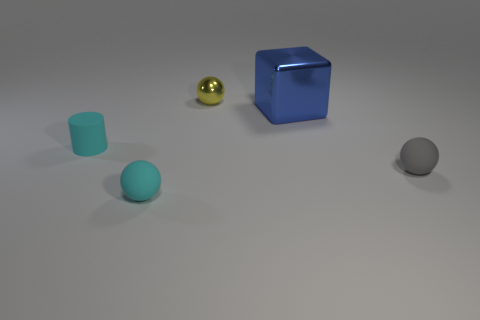Subtract 1 spheres. How many spheres are left? 2 Add 4 tiny red shiny blocks. How many objects exist? 9 Subtract all cylinders. How many objects are left? 4 Subtract 0 purple cylinders. How many objects are left? 5 Subtract all yellow things. Subtract all blue metal things. How many objects are left? 3 Add 3 blue cubes. How many blue cubes are left? 4 Add 4 blue metallic blocks. How many blue metallic blocks exist? 5 